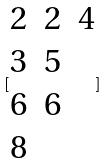Convert formula to latex. <formula><loc_0><loc_0><loc_500><loc_500>[ \begin{matrix} 2 & 2 & 4 \\ 3 & 5 \\ 6 & 6 \\ 8 \end{matrix} ]</formula> 